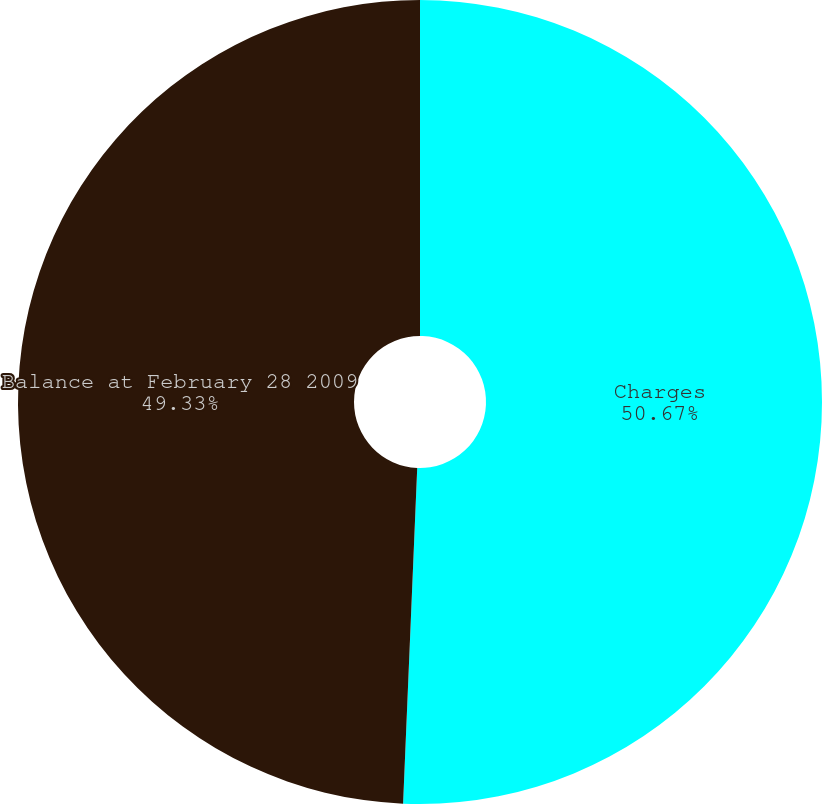<chart> <loc_0><loc_0><loc_500><loc_500><pie_chart><fcel>Charges<fcel>Balance at February 28 2009<nl><fcel>50.67%<fcel>49.33%<nl></chart> 